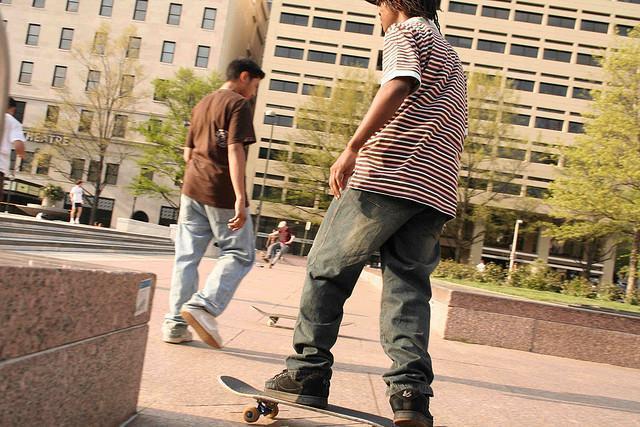How many people are there?
Give a very brief answer. 2. How many toilets are there?
Give a very brief answer. 0. 